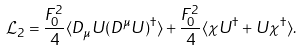Convert formula to latex. <formula><loc_0><loc_0><loc_500><loc_500>\mathcal { L } _ { 2 } = \frac { F _ { 0 } ^ { 2 } } { 4 } \langle D _ { \mu } U ( D ^ { \mu } U ) ^ { \dagger } \rangle + \frac { F _ { 0 } ^ { 2 } } { 4 } \langle \chi U ^ { \dagger } + U \chi ^ { \dagger } \rangle .</formula> 